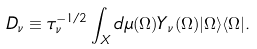Convert formula to latex. <formula><loc_0><loc_0><loc_500><loc_500>D _ { \nu } \equiv \tau _ { \nu } ^ { - 1 / 2 } \int _ { X } d \mu ( \Omega ) Y _ { \nu } ( \Omega ) | \Omega \rangle \langle \Omega | .</formula> 